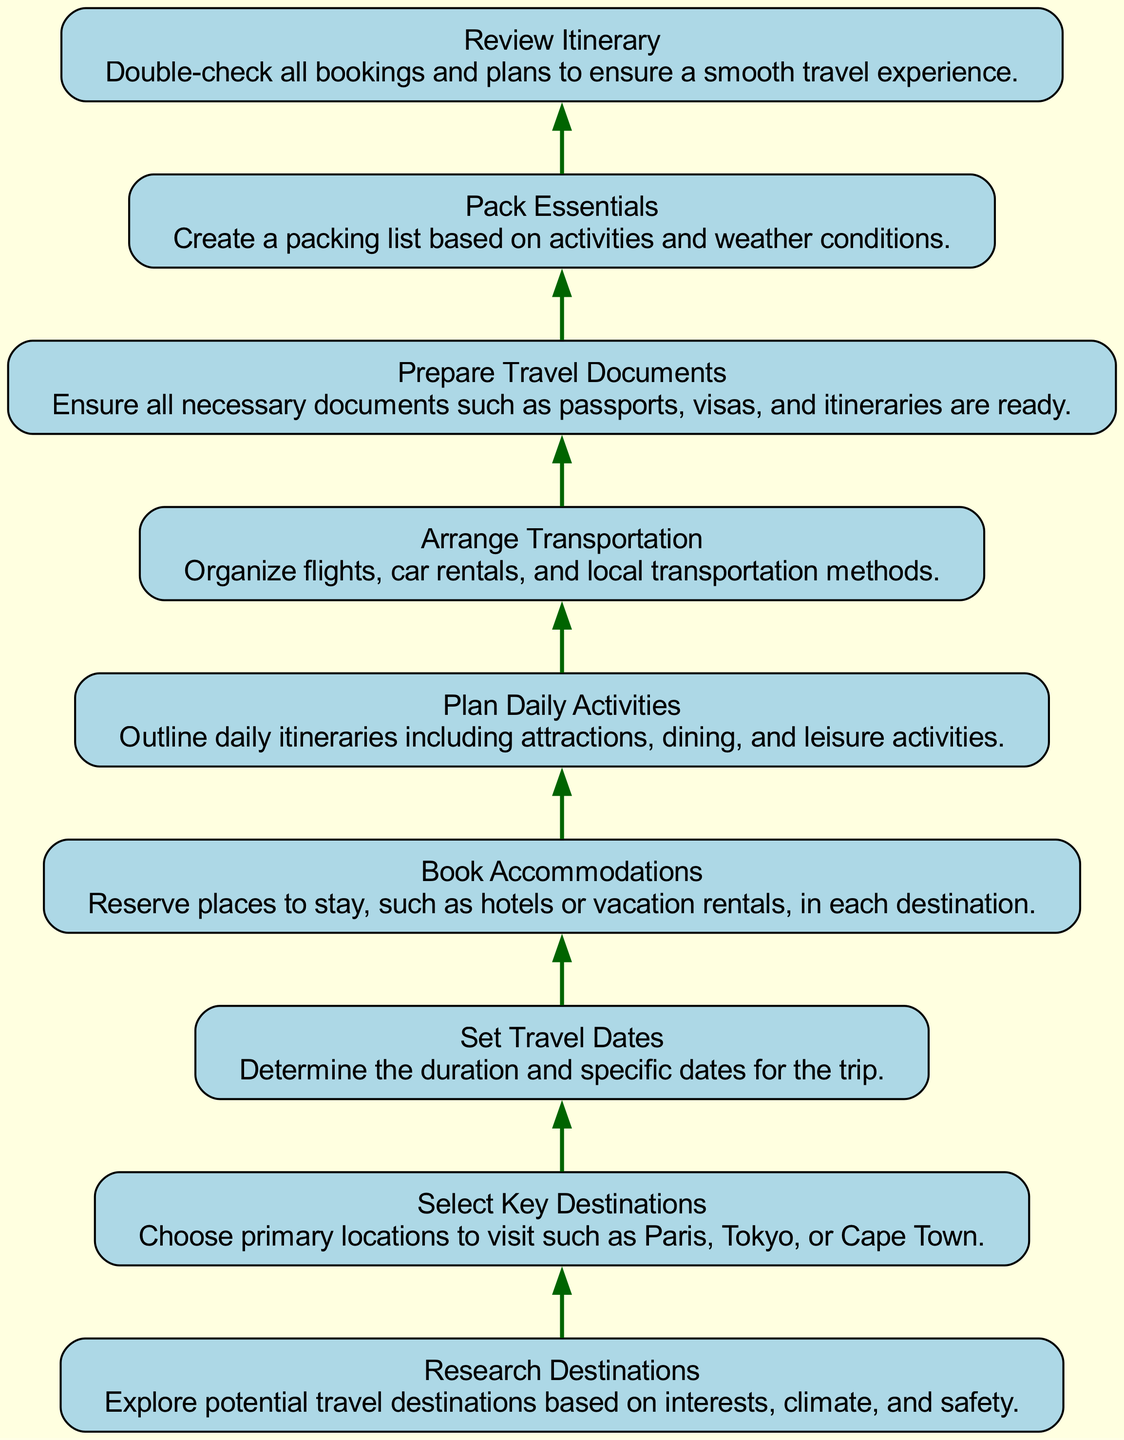What is the first step in the travel itinerary creation process? The first step is "Research Destinations," which involves exploring potential travel destinations based on interests, climate, and safety.
Answer: Research Destinations How many total nodes are shown in the diagram? There are nine nodes representing different steps in the travel itinerary creation process.
Answer: Nine Which step comes directly after booking accommodations? The step that comes directly after "Book Accommodations" is "Plan Daily Activities." This can be inferred by following the flow from the accommodations node to the next node in the diagram.
Answer: Plan Daily Activities What is the last step in the process? The last step is "Review Itinerary," which involves double-checking all bookings and plans to ensure a smooth travel experience. This is confirmed by identifying the final node in the diagram.
Answer: Review Itinerary Which nodes are connected to the "Arrange Transportation" step? "Arrange Transportation" connects to "Plan Daily Activities" as the next step, implying a dependency or sequence in planning travel activities post transportation arrangement.
Answer: Plan Daily Activities How many steps are there between "Select Key Destinations" and "Review Itinerary"? There are five steps in total between "Select Key Destinations" and "Review Itinerary," considering all connecting nodes as part of the flow from selecting destinations to reviewing plans.
Answer: Five What is required before packing essentials? "Prepare Travel Documents" is required before "Pack Essentials." This is the step immediately preceding packing in the flowchart.
Answer: Prepare Travel Documents Does the diagram indicate the necessity of "Set Travel Dates"? Yes, "Set Travel Dates" is a necessary step because it comes before other critical actions, such as booking accommodations and planning daily activities, implying that dates help in organizing these aspects.
Answer: Yes What is the primary purpose of the "Review Itinerary" step? The primary purpose of "Review Itinerary" is to double-check all bookings and plans to ensure a smooth travel experience, thus serving as a final verification step.
Answer: Double-check bookings and plans 